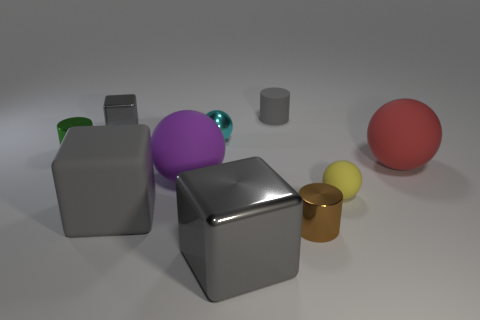Subtract all large gray metallic blocks. How many blocks are left? 2 Subtract all gray cylinders. How many cylinders are left? 2 Subtract all cylinders. How many objects are left? 7 Subtract 2 cylinders. How many cylinders are left? 1 Subtract all gray balls. Subtract all cyan cubes. How many balls are left? 4 Subtract all gray blocks. How many yellow balls are left? 1 Subtract all big green blocks. Subtract all tiny gray rubber things. How many objects are left? 9 Add 6 gray metallic things. How many gray metallic things are left? 8 Add 3 shiny blocks. How many shiny blocks exist? 5 Subtract 0 cyan cylinders. How many objects are left? 10 